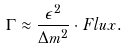Convert formula to latex. <formula><loc_0><loc_0><loc_500><loc_500>\Gamma \approx \frac { \epsilon ^ { 2 } } { \Delta m ^ { 2 } } \cdot F l u x .</formula> 